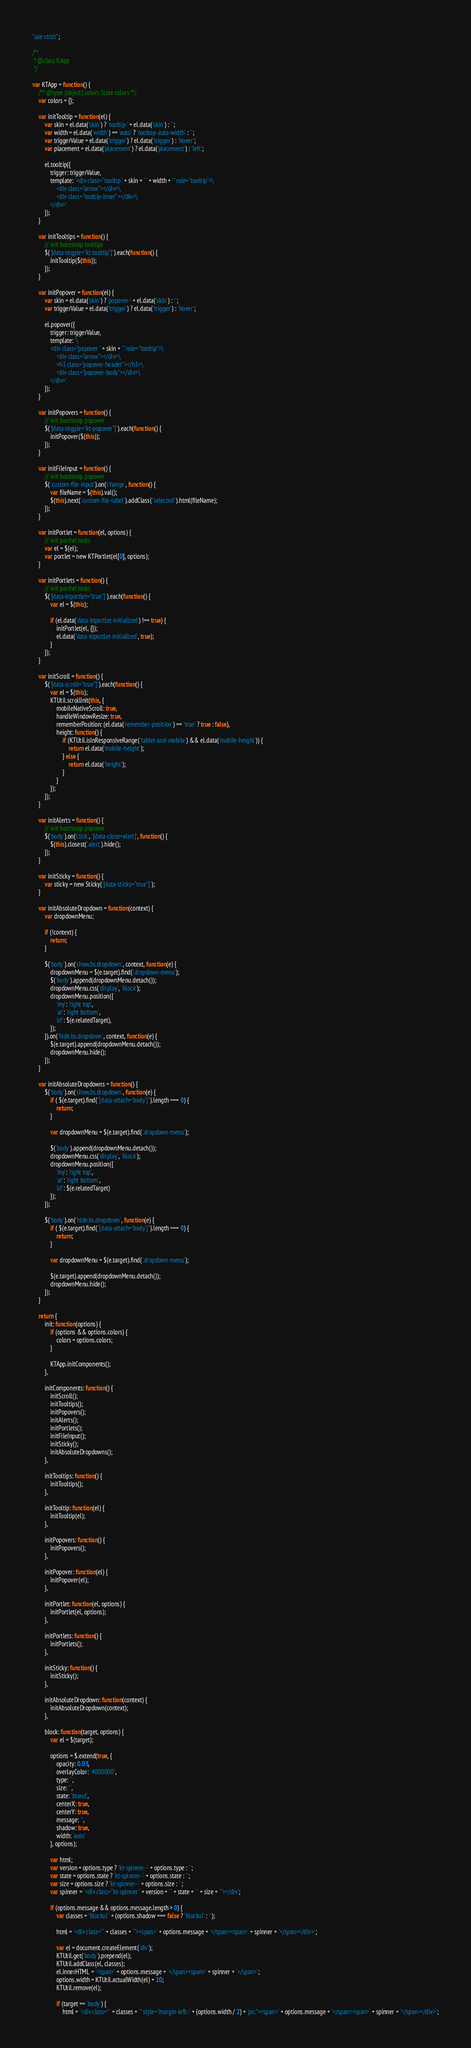Convert code to text. <code><loc_0><loc_0><loc_500><loc_500><_JavaScript_>"use strict";

/**
 * @class KApp
 */

var KTApp = function() {
    /** @type {object} colors State colors **/
    var colors = {};

    var initTooltip = function(el) {
        var skin = el.data('skin') ? 'tooltip-' + el.data('skin') : '';
        var width = el.data('width') == 'auto' ? 'tooltop-auto-width' : '';
        var triggerValue = el.data('trigger') ? el.data('trigger') : 'hover';
        var placement = el.data('placement') ? el.data('placement') : 'left';

        el.tooltip({
            trigger: triggerValue,
            template: '<div class="tooltip ' + skin + ' ' + width + '" role="tooltip">\
                <div class="arrow"></div>\
                <div class="tooltip-inner"></div>\
            </div>'
        });
    }

    var initTooltips = function() {
        // init bootstrap tooltips
        $('[data-toggle="kt-tooltip"]').each(function() {
            initTooltip($(this));
        });
    }

    var initPopover = function(el) {
        var skin = el.data('skin') ? 'popover-' + el.data('skin') : '';
        var triggerValue = el.data('trigger') ? el.data('trigger') : 'hover';

        el.popover({
            trigger: triggerValue,
            template: '\
            <div class="popover ' + skin + '" role="tooltip">\
                <div class="arrow"></div>\
                <h3 class="popover-header"></h3>\
                <div class="popover-body"></div>\
            </div>'
        });
    }

    var initPopovers = function() {
        // init bootstrap popover
        $('[data-toggle="kt-popover"]').each(function() {
            initPopover($(this));
        });
    }

    var initFileInput = function() {
        // init bootstrap popover
        $('.custom-file-input').on('change', function() {
            var fileName = $(this).val();
            $(this).next('.custom-file-label').addClass("selected").html(fileName);
        });
    }

    var initPortlet = function(el, options) {
        // init portlet tools
        var el = $(el);
        var portlet = new KTPortlet(el[0], options);
    }

    var initPortlets = function() {
        // init portlet tools
        $('[data-ktportlet="true"]').each(function() {
            var el = $(this);

            if (el.data('data-ktportlet-initialized') !== true) {
                initPortlet(el, {});
                el.data('data-ktportlet-initialized', true);
            }
        });
    }

    var initScroll = function() {
        $('[data-scroll="true"]').each(function() {
            var el = $(this);
            KTUtil.scrollInit(this, {
                mobileNativeScroll: true,
                handleWindowResize: true,
                rememberPosition: (el.data('remember-position') == 'true' ? true : false),
                height: function() {
                    if (KTUtil.isInResponsiveRange('tablet-and-mobile') && el.data('mobile-height')) {
                        return el.data('mobile-height');
                    } else {
                        return el.data('height');
                    }
                }
            });
        });
    }

    var initAlerts = function() {
        // init bootstrap popover
        $('body').on('click', '[data-close=alert]', function() {
            $(this).closest('.alert').hide();
        });
    }

    var initSticky = function() {
        var sticky = new Sticky('[data-sticky="true"]');
    }

    var initAbsoluteDropdown = function(context) {
        var dropdownMenu;

        if (!context) {
            return;
        }

        $('body').on('show.bs.dropdown', context, function(e) {
        	dropdownMenu = $(e.target).find('.dropdown-menu');
        	$('body').append(dropdownMenu.detach());
        	dropdownMenu.css('display', 'block');
        	dropdownMenu.position({
        		'my': 'right top',
        		'at': 'right bottom',
        		'of': $(e.relatedTarget),
        	});
        }).on('hide.bs.dropdown', context, function(e) {
        	$(e.target).append(dropdownMenu.detach());
        	dropdownMenu.hide();
        });
    }

    var initAbsoluteDropdowns = function() {
        $('body').on('show.bs.dropdown', function(e) {
            if ( $(e.target).find("[data-attach='body']").length === 0) {
                return;
            }

            var dropdownMenu = $(e.target).find('.dropdown-menu');

            $('body').append(dropdownMenu.detach());
            dropdownMenu.css('display', 'block');
            dropdownMenu.position({
                'my': 'right top',
                'at': 'right bottom',
                'of': $(e.relatedTarget)
            });
        });

        $('body').on('hide.bs.dropdown', function(e) {
            if ( $(e.target).find("[data-attach='body']").length === 0) {
                return;
            }

            var dropdownMenu = $(e.target).find('.dropdown-menu');

            $(e.target).append(dropdownMenu.detach());
            dropdownMenu.hide();
        });
    }

    return {
        init: function(options) {
            if (options && options.colors) {
                colors = options.colors;
            }

            KTApp.initComponents();
        },

        initComponents: function() {
            initScroll();
            initTooltips();
            initPopovers();
            initAlerts();
            initPortlets();
            initFileInput();
            initSticky();
            initAbsoluteDropdowns();
        },

        initTooltips: function() {
            initTooltips();
        },

        initTooltip: function(el) {
            initTooltip(el);
        },

        initPopovers: function() {
            initPopovers();
        },

        initPopover: function(el) {
            initPopover(el);
        },

        initPortlet: function(el, options) {
            initPortlet(el, options);
        },

        initPortlets: function() {
            initPortlets();
        },

        initSticky: function() {
            initSticky();
        },

        initAbsoluteDropdown: function(context) {
            initAbsoluteDropdown(context);
        },

        block: function(target, options) {
            var el = $(target);

            options = $.extend(true, {
                opacity: 0.05,
                overlayColor: '#000000',
                type: '',
                size: '',
                state: 'brand',
                centerX: true,
                centerY: true,
                message: '',
                shadow: true,
                width: 'auto'
            }, options);

            var html;
            var version = options.type ? 'kt-spinner--' + options.type : '';
            var state = options.state ? 'kt-spinner--' + options.state : '';
            var size = options.size ? 'kt-spinner--' + options.size : '';
            var spinner = '<div class="kt-spinner ' + version + ' ' + state + ' ' + size + '"></div';

            if (options.message && options.message.length > 0) {
                var classes = 'blockui ' + (options.shadow === false ? 'blockui' : '');

                html = '<div class="' + classes + '"><span>' + options.message + '</span><span>' + spinner + '</span></div>';

                var el = document.createElement('div');
                KTUtil.get('body').prepend(el);
                KTUtil.addClass(el, classes);
                el.innerHTML = '<span>' + options.message + '</span><span>' + spinner + '</span>';
                options.width = KTUtil.actualWidth(el) + 10;
                KTUtil.remove(el);

                if (target == 'body') {
                    html = '<div class="' + classes + '" style="margin-left:-' + (options.width / 2) + 'px;"><span>' + options.message + '</span><span>' + spinner + '</span></div>';</code> 